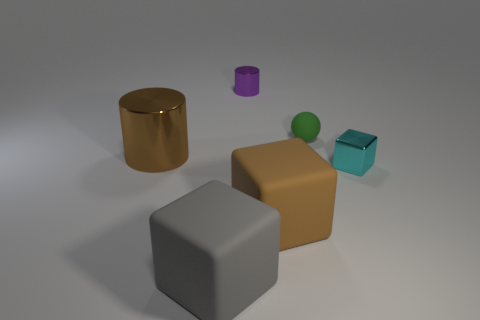Add 4 tiny red matte spheres. How many objects exist? 10 Subtract all cylinders. How many objects are left? 4 Add 5 tiny purple cylinders. How many tiny purple cylinders are left? 6 Add 4 brown matte cubes. How many brown matte cubes exist? 5 Subtract 0 green cubes. How many objects are left? 6 Subtract all big matte cubes. Subtract all big blocks. How many objects are left? 2 